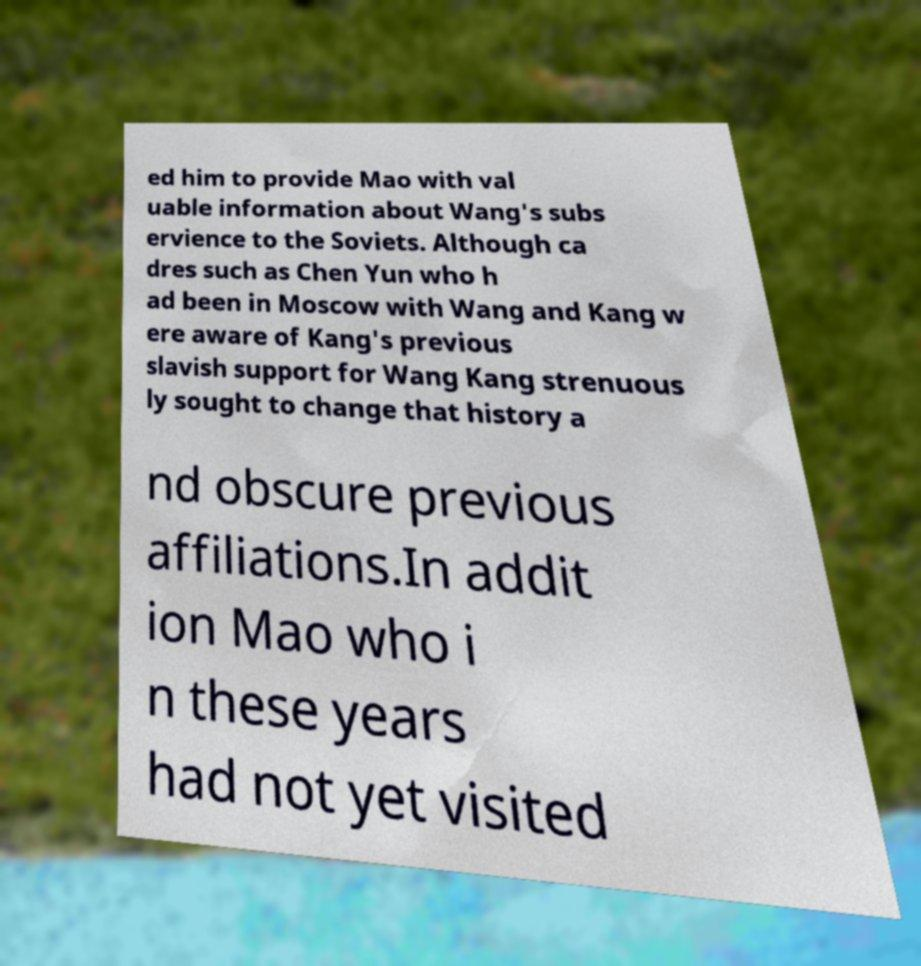Could you extract and type out the text from this image? ed him to provide Mao with val uable information about Wang's subs ervience to the Soviets. Although ca dres such as Chen Yun who h ad been in Moscow with Wang and Kang w ere aware of Kang's previous slavish support for Wang Kang strenuous ly sought to change that history a nd obscure previous affiliations.In addit ion Mao who i n these years had not yet visited 